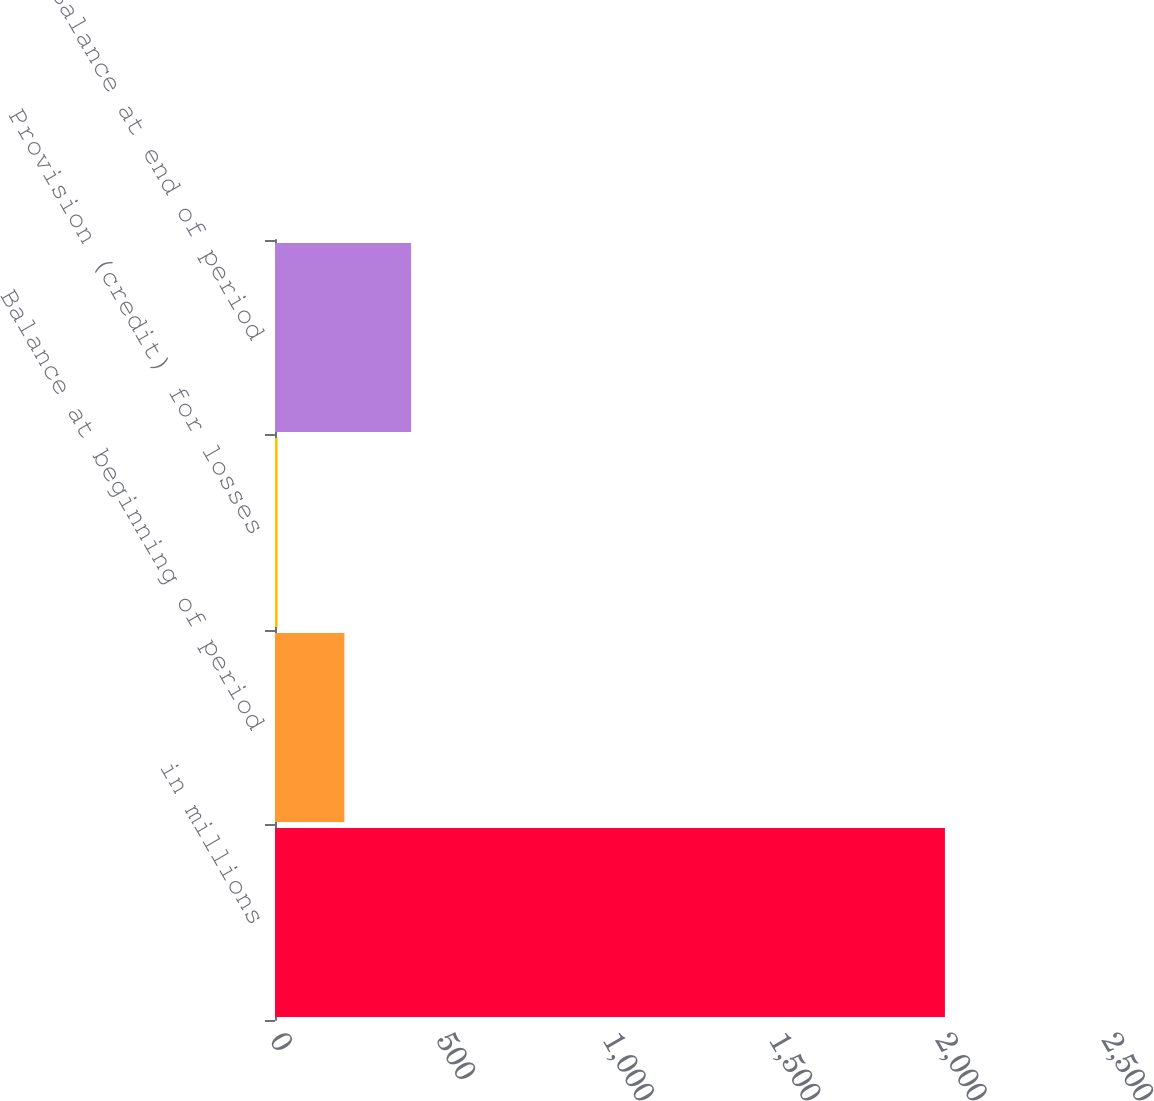<chart> <loc_0><loc_0><loc_500><loc_500><bar_chart><fcel>in millions<fcel>Balance at beginning of period<fcel>Provision (credit) for losses<fcel>Balance at end of period<nl><fcel>2013<fcel>208.5<fcel>8<fcel>409<nl></chart> 